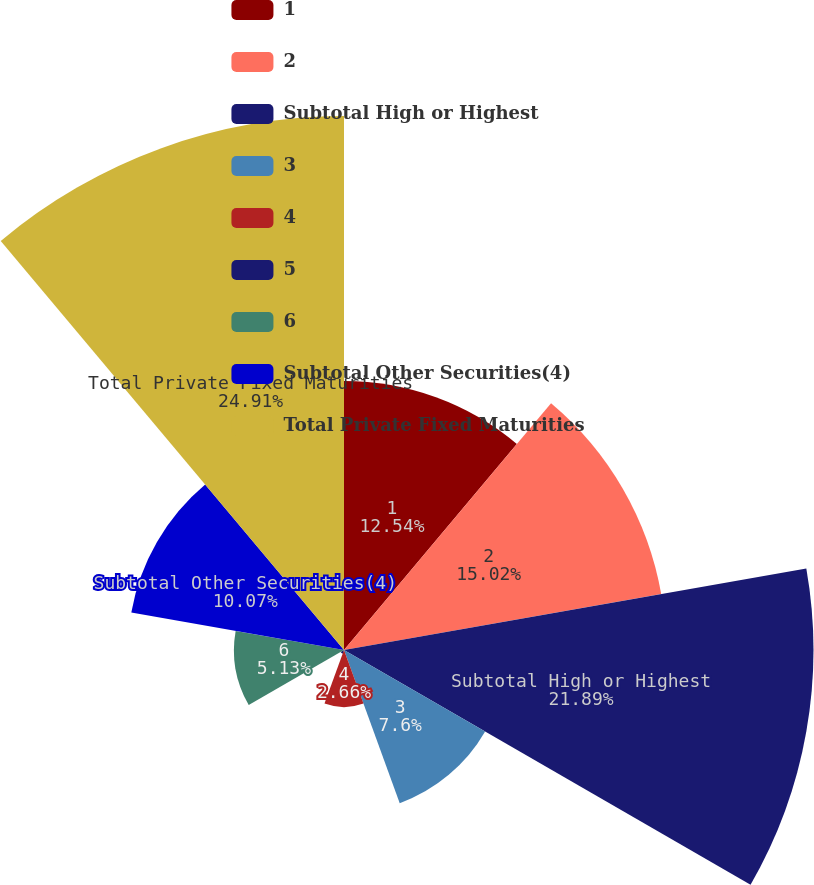Convert chart. <chart><loc_0><loc_0><loc_500><loc_500><pie_chart><fcel>1<fcel>2<fcel>Subtotal High or Highest<fcel>3<fcel>4<fcel>5<fcel>6<fcel>Subtotal Other Securities(4)<fcel>Total Private Fixed Maturities<nl><fcel>12.54%<fcel>15.02%<fcel>21.89%<fcel>7.6%<fcel>2.66%<fcel>0.18%<fcel>5.13%<fcel>10.07%<fcel>24.9%<nl></chart> 